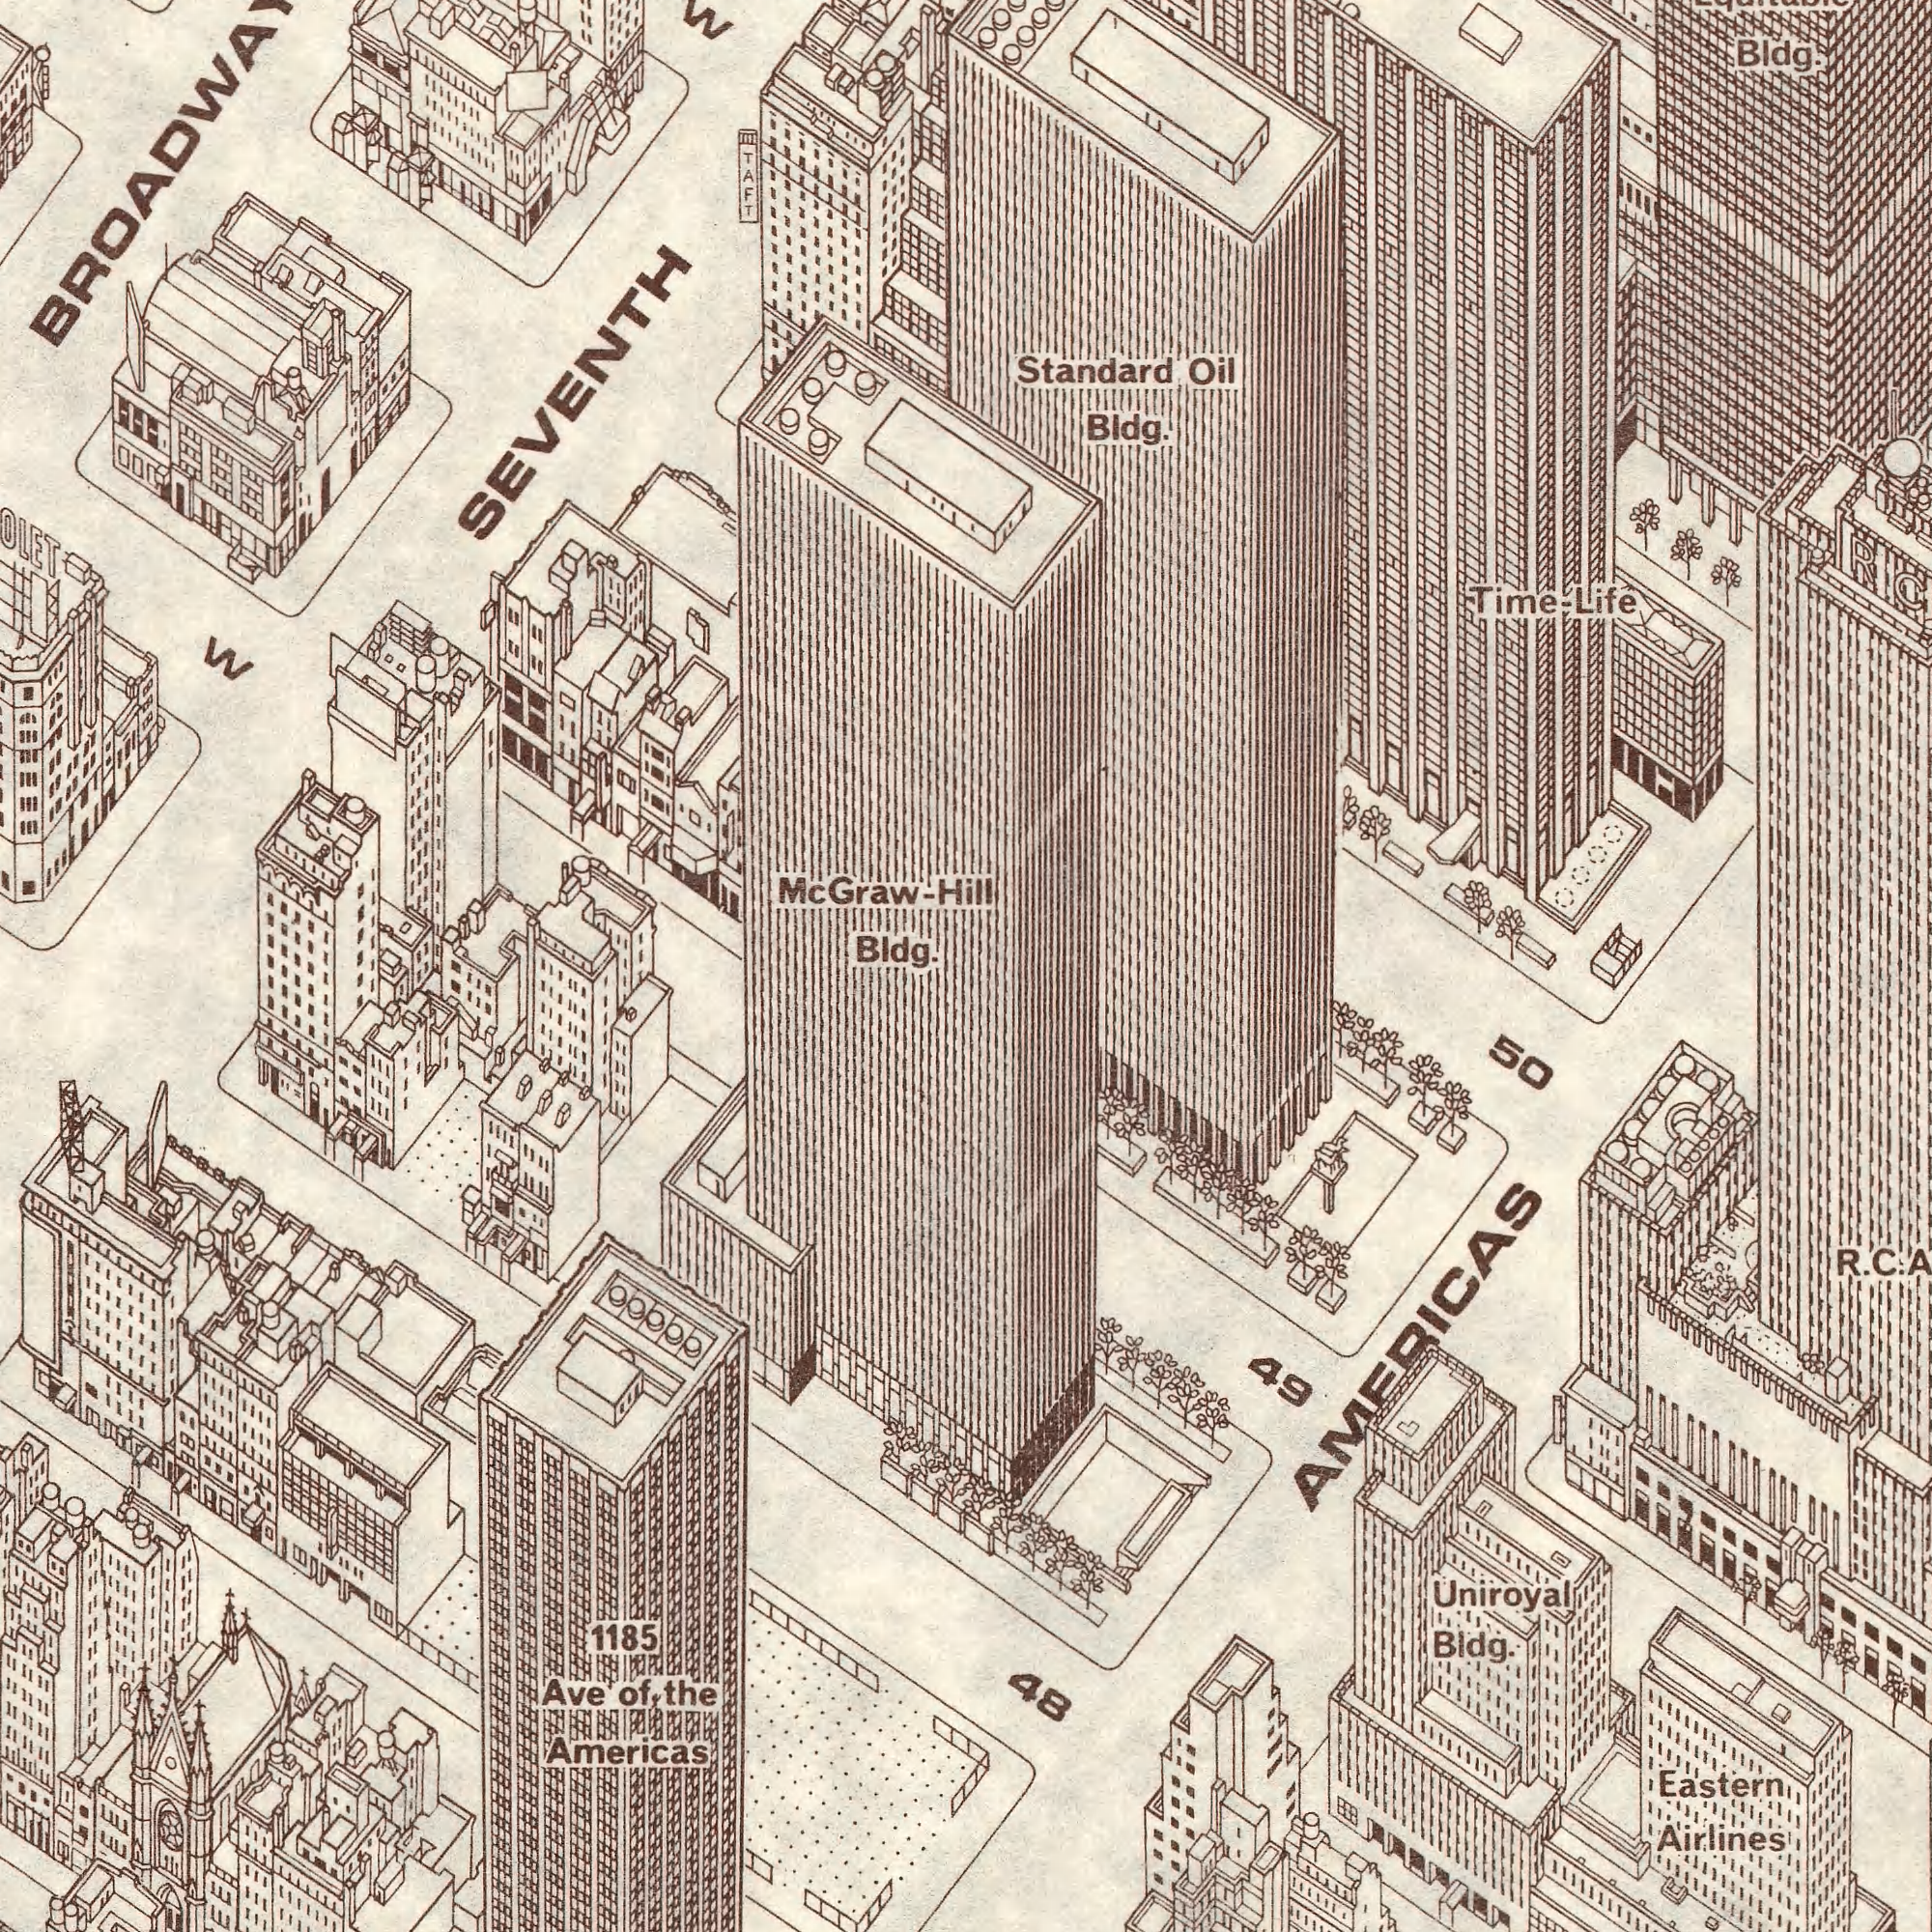What text can you see in the bottom-right section? Uniroyal Bldg. 50 49 AMERICAS Airlines Eastern R. C. What text can you see in the top-left section? W Hill SEVENTH McGraw- TAFT What text appears in the top-right area of the image? Standard Bldg. Bldg. Oil Life Time- What text can you see in the bottom-left section? Bldg. Ave 1185 Americas of the 48 